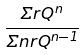<formula> <loc_0><loc_0><loc_500><loc_500>\frac { \Sigma r Q ^ { n } } { \Sigma n r Q ^ { n - 1 } }</formula> 